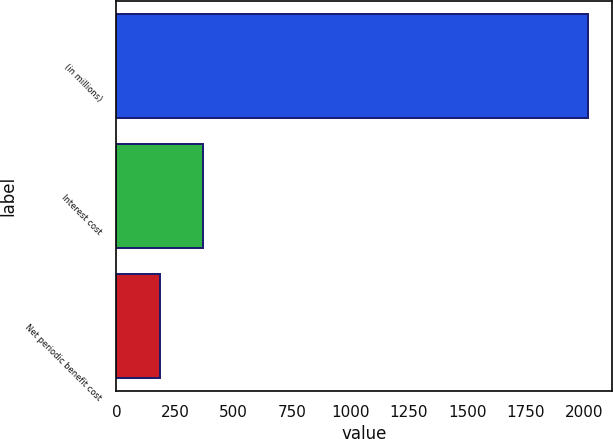Convert chart. <chart><loc_0><loc_0><loc_500><loc_500><bar_chart><fcel>(in millions)<fcel>Interest cost<fcel>Net periodic benefit cost<nl><fcel>2015<fcel>369.8<fcel>187<nl></chart> 